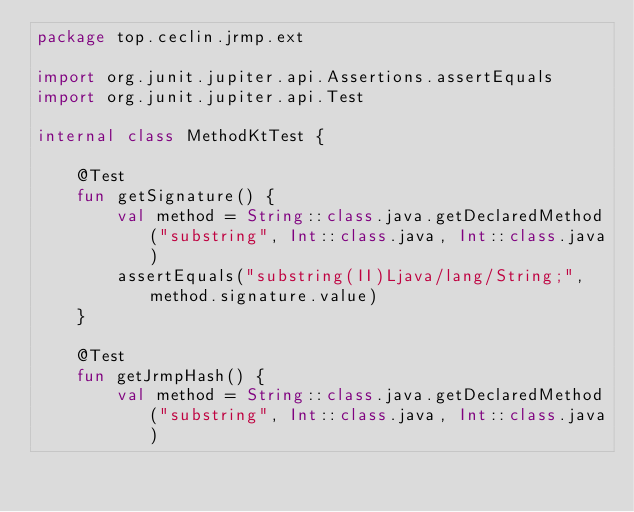<code> <loc_0><loc_0><loc_500><loc_500><_Kotlin_>package top.ceclin.jrmp.ext

import org.junit.jupiter.api.Assertions.assertEquals
import org.junit.jupiter.api.Test

internal class MethodKtTest {

    @Test
    fun getSignature() {
        val method = String::class.java.getDeclaredMethod("substring", Int::class.java, Int::class.java)
        assertEquals("substring(II)Ljava/lang/String;", method.signature.value)
    }

    @Test
    fun getJrmpHash() {
        val method = String::class.java.getDeclaredMethod("substring", Int::class.java, Int::class.java)</code> 